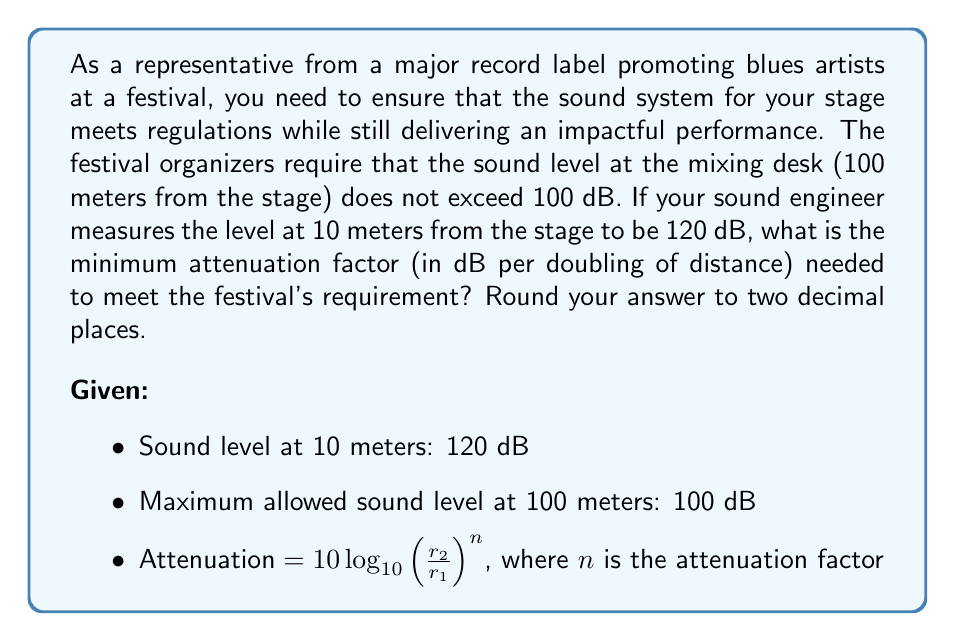Can you solve this math problem? To solve this problem, we need to use the logarithmic relationship between sound intensity and distance, along with the given information.

1) First, let's calculate how many times the distance doubles from 10 meters to 100 meters:
   $100 = 10 \cdot 2^x$
   $2^x = 10$
   $x = \log_2(10) \approx 3.32$

   So the distance doubles approximately 3.32 times.

2) Now, we can set up our equation using the attenuation formula:
   $120 - 100 = 10 \log_{10}(2^{3.32})^n$

3) Simplify the right side:
   $20 = 10 \cdot 3.32 \cdot n \cdot \log_{10}(2)$

4) Solve for $n$:
   $n = \frac{20}{10 \cdot 3.32 \cdot \log_{10}(2)}$

5) Calculate:
   $n = \frac{20}{10 \cdot 3.32 \cdot 0.30103} \approx 2.0055$

6) Round to two decimal places:
   $n \approx 2.01$

Therefore, the minimum attenuation factor needed is approximately 2.01 dB per doubling of distance.
Answer: The minimum attenuation factor needed is 2.01 dB per doubling of distance. 